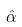Convert formula to latex. <formula><loc_0><loc_0><loc_500><loc_500>\hat { \alpha }</formula> 